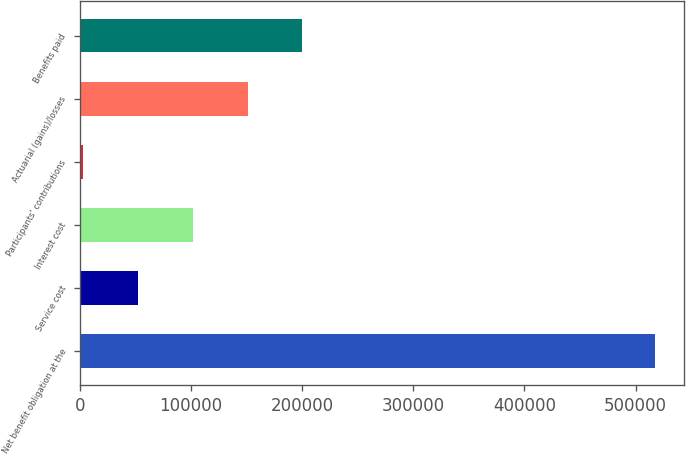Convert chart. <chart><loc_0><loc_0><loc_500><loc_500><bar_chart><fcel>Net benefit obligation at the<fcel>Service cost<fcel>Interest cost<fcel>Participants' contributions<fcel>Actuarial (gains)/losses<fcel>Benefits paid<nl><fcel>517708<fcel>52364.3<fcel>101634<fcel>3095<fcel>150903<fcel>200172<nl></chart> 